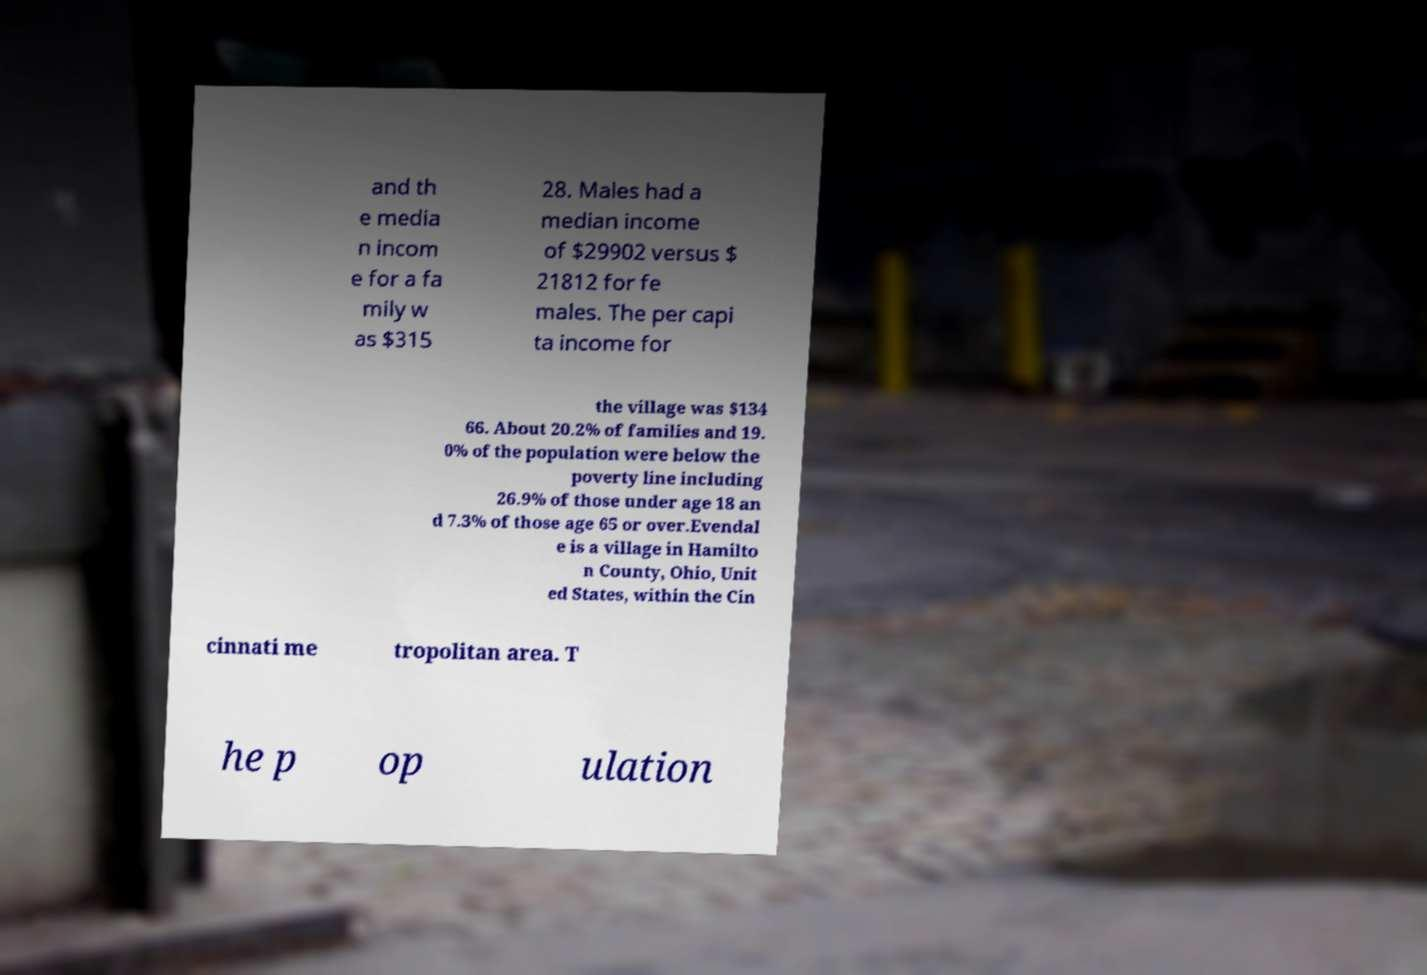Could you assist in decoding the text presented in this image and type it out clearly? and th e media n incom e for a fa mily w as $315 28. Males had a median income of $29902 versus $ 21812 for fe males. The per capi ta income for the village was $134 66. About 20.2% of families and 19. 0% of the population were below the poverty line including 26.9% of those under age 18 an d 7.3% of those age 65 or over.Evendal e is a village in Hamilto n County, Ohio, Unit ed States, within the Cin cinnati me tropolitan area. T he p op ulation 